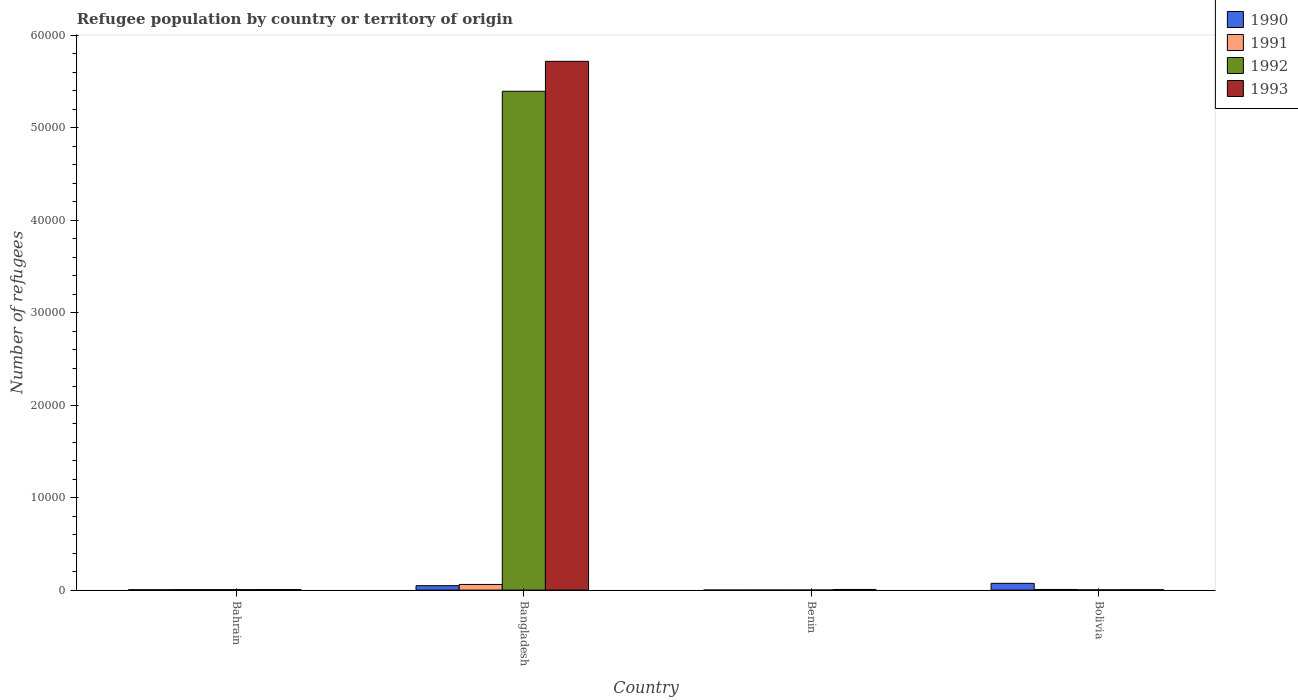How many different coloured bars are there?
Provide a short and direct response. 4. How many groups of bars are there?
Give a very brief answer. 4. Are the number of bars per tick equal to the number of legend labels?
Your response must be concise. Yes. How many bars are there on the 4th tick from the right?
Make the answer very short. 4. What is the label of the 2nd group of bars from the left?
Make the answer very short. Bangladesh. In how many cases, is the number of bars for a given country not equal to the number of legend labels?
Offer a very short reply. 0. Across all countries, what is the maximum number of refugees in 1990?
Ensure brevity in your answer.  731. In which country was the number of refugees in 1992 maximum?
Keep it short and to the point. Bangladesh. In which country was the number of refugees in 1991 minimum?
Keep it short and to the point. Benin. What is the total number of refugees in 1992 in the graph?
Your answer should be very brief. 5.40e+04. What is the difference between the number of refugees in 1991 in Benin and that in Bolivia?
Your response must be concise. -63. What is the difference between the number of refugees in 1990 in Benin and the number of refugees in 1992 in Bangladesh?
Provide a succinct answer. -5.39e+04. What is the average number of refugees in 1992 per country?
Your answer should be very brief. 1.35e+04. What is the difference between the number of refugees of/in 1990 and number of refugees of/in 1993 in Bahrain?
Your response must be concise. -21. What is the ratio of the number of refugees in 1990 in Bahrain to that in Bolivia?
Give a very brief answer. 0.05. What is the difference between the highest and the second highest number of refugees in 1991?
Provide a short and direct response. -544. What is the difference between the highest and the lowest number of refugees in 1993?
Keep it short and to the point. 5.71e+04. Are all the bars in the graph horizontal?
Ensure brevity in your answer.  No. How many countries are there in the graph?
Provide a succinct answer. 4. What is the difference between two consecutive major ticks on the Y-axis?
Your answer should be compact. 10000. Are the values on the major ticks of Y-axis written in scientific E-notation?
Offer a very short reply. No. Does the graph contain grids?
Provide a short and direct response. No. How many legend labels are there?
Your answer should be compact. 4. What is the title of the graph?
Keep it short and to the point. Refugee population by country or territory of origin. Does "1968" appear as one of the legend labels in the graph?
Provide a succinct answer. No. What is the label or title of the X-axis?
Make the answer very short. Country. What is the label or title of the Y-axis?
Your response must be concise. Number of refugees. What is the Number of refugees of 1990 in Bahrain?
Give a very brief answer. 39. What is the Number of refugees of 1991 in Bahrain?
Your answer should be compact. 52. What is the Number of refugees in 1993 in Bahrain?
Provide a succinct answer. 60. What is the Number of refugees in 1990 in Bangladesh?
Give a very brief answer. 477. What is the Number of refugees of 1991 in Bangladesh?
Provide a short and direct response. 611. What is the Number of refugees in 1992 in Bangladesh?
Keep it short and to the point. 5.39e+04. What is the Number of refugees in 1993 in Bangladesh?
Offer a terse response. 5.72e+04. What is the Number of refugees of 1990 in Bolivia?
Your answer should be very brief. 731. What is the Number of refugees in 1993 in Bolivia?
Your response must be concise. 41. Across all countries, what is the maximum Number of refugees of 1990?
Make the answer very short. 731. Across all countries, what is the maximum Number of refugees of 1991?
Ensure brevity in your answer.  611. Across all countries, what is the maximum Number of refugees in 1992?
Your response must be concise. 5.39e+04. Across all countries, what is the maximum Number of refugees in 1993?
Your answer should be very brief. 5.72e+04. Across all countries, what is the minimum Number of refugees of 1990?
Your answer should be compact. 2. Across all countries, what is the minimum Number of refugees in 1993?
Provide a succinct answer. 41. What is the total Number of refugees in 1990 in the graph?
Offer a terse response. 1249. What is the total Number of refugees of 1991 in the graph?
Provide a succinct answer. 734. What is the total Number of refugees in 1992 in the graph?
Provide a short and direct response. 5.40e+04. What is the total Number of refugees of 1993 in the graph?
Your answer should be compact. 5.73e+04. What is the difference between the Number of refugees in 1990 in Bahrain and that in Bangladesh?
Provide a short and direct response. -438. What is the difference between the Number of refugees of 1991 in Bahrain and that in Bangladesh?
Keep it short and to the point. -559. What is the difference between the Number of refugees in 1992 in Bahrain and that in Bangladesh?
Your answer should be compact. -5.39e+04. What is the difference between the Number of refugees in 1993 in Bahrain and that in Bangladesh?
Give a very brief answer. -5.71e+04. What is the difference between the Number of refugees in 1992 in Bahrain and that in Benin?
Offer a terse response. 49. What is the difference between the Number of refugees in 1993 in Bahrain and that in Benin?
Provide a succinct answer. -8. What is the difference between the Number of refugees of 1990 in Bahrain and that in Bolivia?
Provide a short and direct response. -692. What is the difference between the Number of refugees of 1992 in Bahrain and that in Bolivia?
Your answer should be compact. 25. What is the difference between the Number of refugees in 1993 in Bahrain and that in Bolivia?
Offer a very short reply. 19. What is the difference between the Number of refugees of 1990 in Bangladesh and that in Benin?
Give a very brief answer. 475. What is the difference between the Number of refugees in 1991 in Bangladesh and that in Benin?
Your response must be concise. 607. What is the difference between the Number of refugees in 1992 in Bangladesh and that in Benin?
Your answer should be very brief. 5.39e+04. What is the difference between the Number of refugees in 1993 in Bangladesh and that in Benin?
Give a very brief answer. 5.71e+04. What is the difference between the Number of refugees of 1990 in Bangladesh and that in Bolivia?
Provide a succinct answer. -254. What is the difference between the Number of refugees in 1991 in Bangladesh and that in Bolivia?
Offer a terse response. 544. What is the difference between the Number of refugees of 1992 in Bangladesh and that in Bolivia?
Your answer should be compact. 5.39e+04. What is the difference between the Number of refugees in 1993 in Bangladesh and that in Bolivia?
Your response must be concise. 5.71e+04. What is the difference between the Number of refugees in 1990 in Benin and that in Bolivia?
Offer a terse response. -729. What is the difference between the Number of refugees in 1991 in Benin and that in Bolivia?
Provide a succinct answer. -63. What is the difference between the Number of refugees in 1990 in Bahrain and the Number of refugees in 1991 in Bangladesh?
Keep it short and to the point. -572. What is the difference between the Number of refugees of 1990 in Bahrain and the Number of refugees of 1992 in Bangladesh?
Offer a terse response. -5.39e+04. What is the difference between the Number of refugees in 1990 in Bahrain and the Number of refugees in 1993 in Bangladesh?
Give a very brief answer. -5.71e+04. What is the difference between the Number of refugees in 1991 in Bahrain and the Number of refugees in 1992 in Bangladesh?
Offer a terse response. -5.39e+04. What is the difference between the Number of refugees in 1991 in Bahrain and the Number of refugees in 1993 in Bangladesh?
Offer a terse response. -5.71e+04. What is the difference between the Number of refugees in 1992 in Bahrain and the Number of refugees in 1993 in Bangladesh?
Make the answer very short. -5.71e+04. What is the difference between the Number of refugees of 1990 in Bahrain and the Number of refugees of 1993 in Benin?
Keep it short and to the point. -29. What is the difference between the Number of refugees of 1990 in Bahrain and the Number of refugees of 1991 in Bolivia?
Ensure brevity in your answer.  -28. What is the difference between the Number of refugees in 1990 in Bahrain and the Number of refugees in 1993 in Bolivia?
Provide a short and direct response. -2. What is the difference between the Number of refugees of 1991 in Bahrain and the Number of refugees of 1992 in Bolivia?
Keep it short and to the point. 24. What is the difference between the Number of refugees in 1991 in Bahrain and the Number of refugees in 1993 in Bolivia?
Offer a terse response. 11. What is the difference between the Number of refugees of 1992 in Bahrain and the Number of refugees of 1993 in Bolivia?
Provide a short and direct response. 12. What is the difference between the Number of refugees in 1990 in Bangladesh and the Number of refugees in 1991 in Benin?
Offer a very short reply. 473. What is the difference between the Number of refugees of 1990 in Bangladesh and the Number of refugees of 1992 in Benin?
Keep it short and to the point. 473. What is the difference between the Number of refugees of 1990 in Bangladesh and the Number of refugees of 1993 in Benin?
Your answer should be very brief. 409. What is the difference between the Number of refugees of 1991 in Bangladesh and the Number of refugees of 1992 in Benin?
Ensure brevity in your answer.  607. What is the difference between the Number of refugees of 1991 in Bangladesh and the Number of refugees of 1993 in Benin?
Your response must be concise. 543. What is the difference between the Number of refugees of 1992 in Bangladesh and the Number of refugees of 1993 in Benin?
Give a very brief answer. 5.39e+04. What is the difference between the Number of refugees of 1990 in Bangladesh and the Number of refugees of 1991 in Bolivia?
Provide a short and direct response. 410. What is the difference between the Number of refugees in 1990 in Bangladesh and the Number of refugees in 1992 in Bolivia?
Provide a succinct answer. 449. What is the difference between the Number of refugees of 1990 in Bangladesh and the Number of refugees of 1993 in Bolivia?
Provide a short and direct response. 436. What is the difference between the Number of refugees in 1991 in Bangladesh and the Number of refugees in 1992 in Bolivia?
Your answer should be compact. 583. What is the difference between the Number of refugees in 1991 in Bangladesh and the Number of refugees in 1993 in Bolivia?
Give a very brief answer. 570. What is the difference between the Number of refugees in 1992 in Bangladesh and the Number of refugees in 1993 in Bolivia?
Your answer should be very brief. 5.39e+04. What is the difference between the Number of refugees in 1990 in Benin and the Number of refugees in 1991 in Bolivia?
Your answer should be compact. -65. What is the difference between the Number of refugees of 1990 in Benin and the Number of refugees of 1992 in Bolivia?
Keep it short and to the point. -26. What is the difference between the Number of refugees in 1990 in Benin and the Number of refugees in 1993 in Bolivia?
Keep it short and to the point. -39. What is the difference between the Number of refugees of 1991 in Benin and the Number of refugees of 1993 in Bolivia?
Provide a succinct answer. -37. What is the difference between the Number of refugees of 1992 in Benin and the Number of refugees of 1993 in Bolivia?
Your answer should be very brief. -37. What is the average Number of refugees of 1990 per country?
Ensure brevity in your answer.  312.25. What is the average Number of refugees in 1991 per country?
Offer a very short reply. 183.5. What is the average Number of refugees of 1992 per country?
Your answer should be very brief. 1.35e+04. What is the average Number of refugees in 1993 per country?
Ensure brevity in your answer.  1.43e+04. What is the difference between the Number of refugees of 1990 and Number of refugees of 1993 in Bahrain?
Offer a terse response. -21. What is the difference between the Number of refugees in 1991 and Number of refugees in 1992 in Bahrain?
Your response must be concise. -1. What is the difference between the Number of refugees in 1992 and Number of refugees in 1993 in Bahrain?
Make the answer very short. -7. What is the difference between the Number of refugees of 1990 and Number of refugees of 1991 in Bangladesh?
Give a very brief answer. -134. What is the difference between the Number of refugees in 1990 and Number of refugees in 1992 in Bangladesh?
Provide a short and direct response. -5.34e+04. What is the difference between the Number of refugees in 1990 and Number of refugees in 1993 in Bangladesh?
Provide a short and direct response. -5.67e+04. What is the difference between the Number of refugees in 1991 and Number of refugees in 1992 in Bangladesh?
Provide a short and direct response. -5.33e+04. What is the difference between the Number of refugees of 1991 and Number of refugees of 1993 in Bangladesh?
Give a very brief answer. -5.65e+04. What is the difference between the Number of refugees of 1992 and Number of refugees of 1993 in Bangladesh?
Provide a short and direct response. -3237. What is the difference between the Number of refugees of 1990 and Number of refugees of 1993 in Benin?
Give a very brief answer. -66. What is the difference between the Number of refugees in 1991 and Number of refugees in 1993 in Benin?
Give a very brief answer. -64. What is the difference between the Number of refugees of 1992 and Number of refugees of 1993 in Benin?
Offer a terse response. -64. What is the difference between the Number of refugees of 1990 and Number of refugees of 1991 in Bolivia?
Offer a terse response. 664. What is the difference between the Number of refugees of 1990 and Number of refugees of 1992 in Bolivia?
Your response must be concise. 703. What is the difference between the Number of refugees in 1990 and Number of refugees in 1993 in Bolivia?
Make the answer very short. 690. What is the difference between the Number of refugees in 1992 and Number of refugees in 1993 in Bolivia?
Your answer should be compact. -13. What is the ratio of the Number of refugees in 1990 in Bahrain to that in Bangladesh?
Your response must be concise. 0.08. What is the ratio of the Number of refugees of 1991 in Bahrain to that in Bangladesh?
Ensure brevity in your answer.  0.09. What is the ratio of the Number of refugees in 1990 in Bahrain to that in Benin?
Offer a very short reply. 19.5. What is the ratio of the Number of refugees in 1992 in Bahrain to that in Benin?
Provide a succinct answer. 13.25. What is the ratio of the Number of refugees in 1993 in Bahrain to that in Benin?
Your answer should be compact. 0.88. What is the ratio of the Number of refugees of 1990 in Bahrain to that in Bolivia?
Your answer should be very brief. 0.05. What is the ratio of the Number of refugees of 1991 in Bahrain to that in Bolivia?
Provide a succinct answer. 0.78. What is the ratio of the Number of refugees of 1992 in Bahrain to that in Bolivia?
Provide a short and direct response. 1.89. What is the ratio of the Number of refugees of 1993 in Bahrain to that in Bolivia?
Keep it short and to the point. 1.46. What is the ratio of the Number of refugees of 1990 in Bangladesh to that in Benin?
Your answer should be compact. 238.5. What is the ratio of the Number of refugees in 1991 in Bangladesh to that in Benin?
Offer a terse response. 152.75. What is the ratio of the Number of refugees of 1992 in Bangladesh to that in Benin?
Your response must be concise. 1.35e+04. What is the ratio of the Number of refugees of 1993 in Bangladesh to that in Benin?
Keep it short and to the point. 840.56. What is the ratio of the Number of refugees of 1990 in Bangladesh to that in Bolivia?
Offer a terse response. 0.65. What is the ratio of the Number of refugees of 1991 in Bangladesh to that in Bolivia?
Keep it short and to the point. 9.12. What is the ratio of the Number of refugees in 1992 in Bangladesh to that in Bolivia?
Ensure brevity in your answer.  1925.75. What is the ratio of the Number of refugees of 1993 in Bangladesh to that in Bolivia?
Your response must be concise. 1394.1. What is the ratio of the Number of refugees of 1990 in Benin to that in Bolivia?
Offer a terse response. 0. What is the ratio of the Number of refugees in 1991 in Benin to that in Bolivia?
Keep it short and to the point. 0.06. What is the ratio of the Number of refugees in 1992 in Benin to that in Bolivia?
Ensure brevity in your answer.  0.14. What is the ratio of the Number of refugees in 1993 in Benin to that in Bolivia?
Your response must be concise. 1.66. What is the difference between the highest and the second highest Number of refugees in 1990?
Give a very brief answer. 254. What is the difference between the highest and the second highest Number of refugees of 1991?
Offer a very short reply. 544. What is the difference between the highest and the second highest Number of refugees of 1992?
Keep it short and to the point. 5.39e+04. What is the difference between the highest and the second highest Number of refugees in 1993?
Provide a short and direct response. 5.71e+04. What is the difference between the highest and the lowest Number of refugees in 1990?
Your response must be concise. 729. What is the difference between the highest and the lowest Number of refugees of 1991?
Offer a terse response. 607. What is the difference between the highest and the lowest Number of refugees of 1992?
Offer a terse response. 5.39e+04. What is the difference between the highest and the lowest Number of refugees in 1993?
Offer a very short reply. 5.71e+04. 